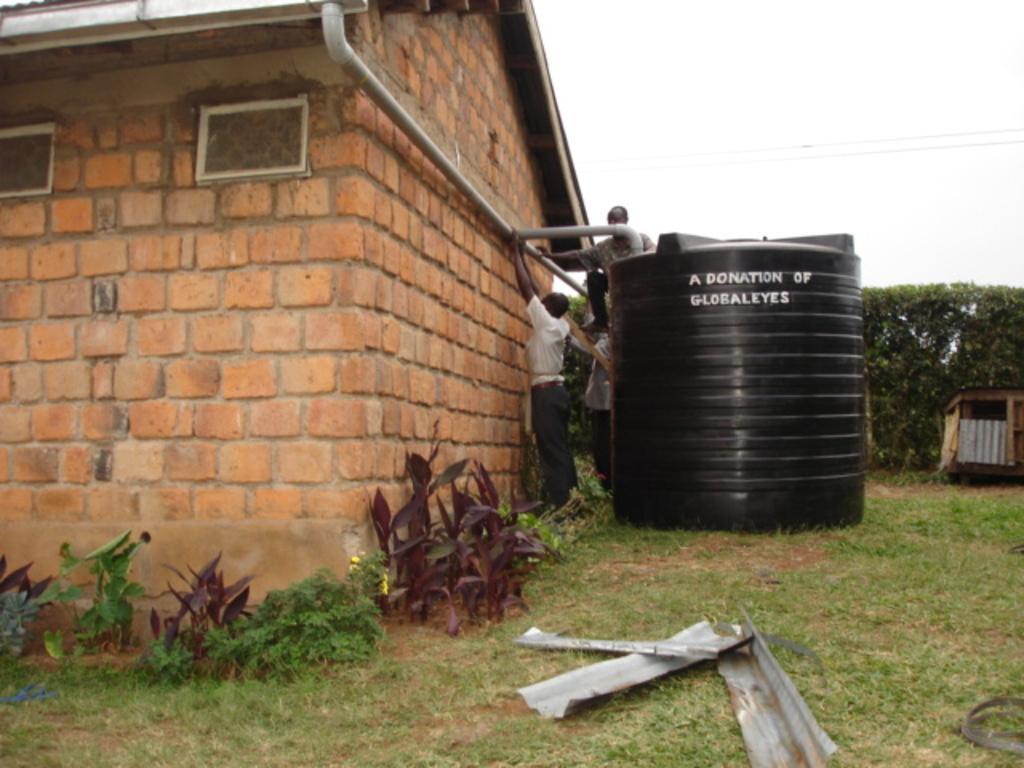Can you describe this image briefly? This picture is clicked outside. In the foreground there are some objects placed on the ground. On the left we can see the plants and a house we can see the group of persons holding some objects. In the center there is a black color tanker placed on the ground. In the background we can see the plants and the cables and the sky. 